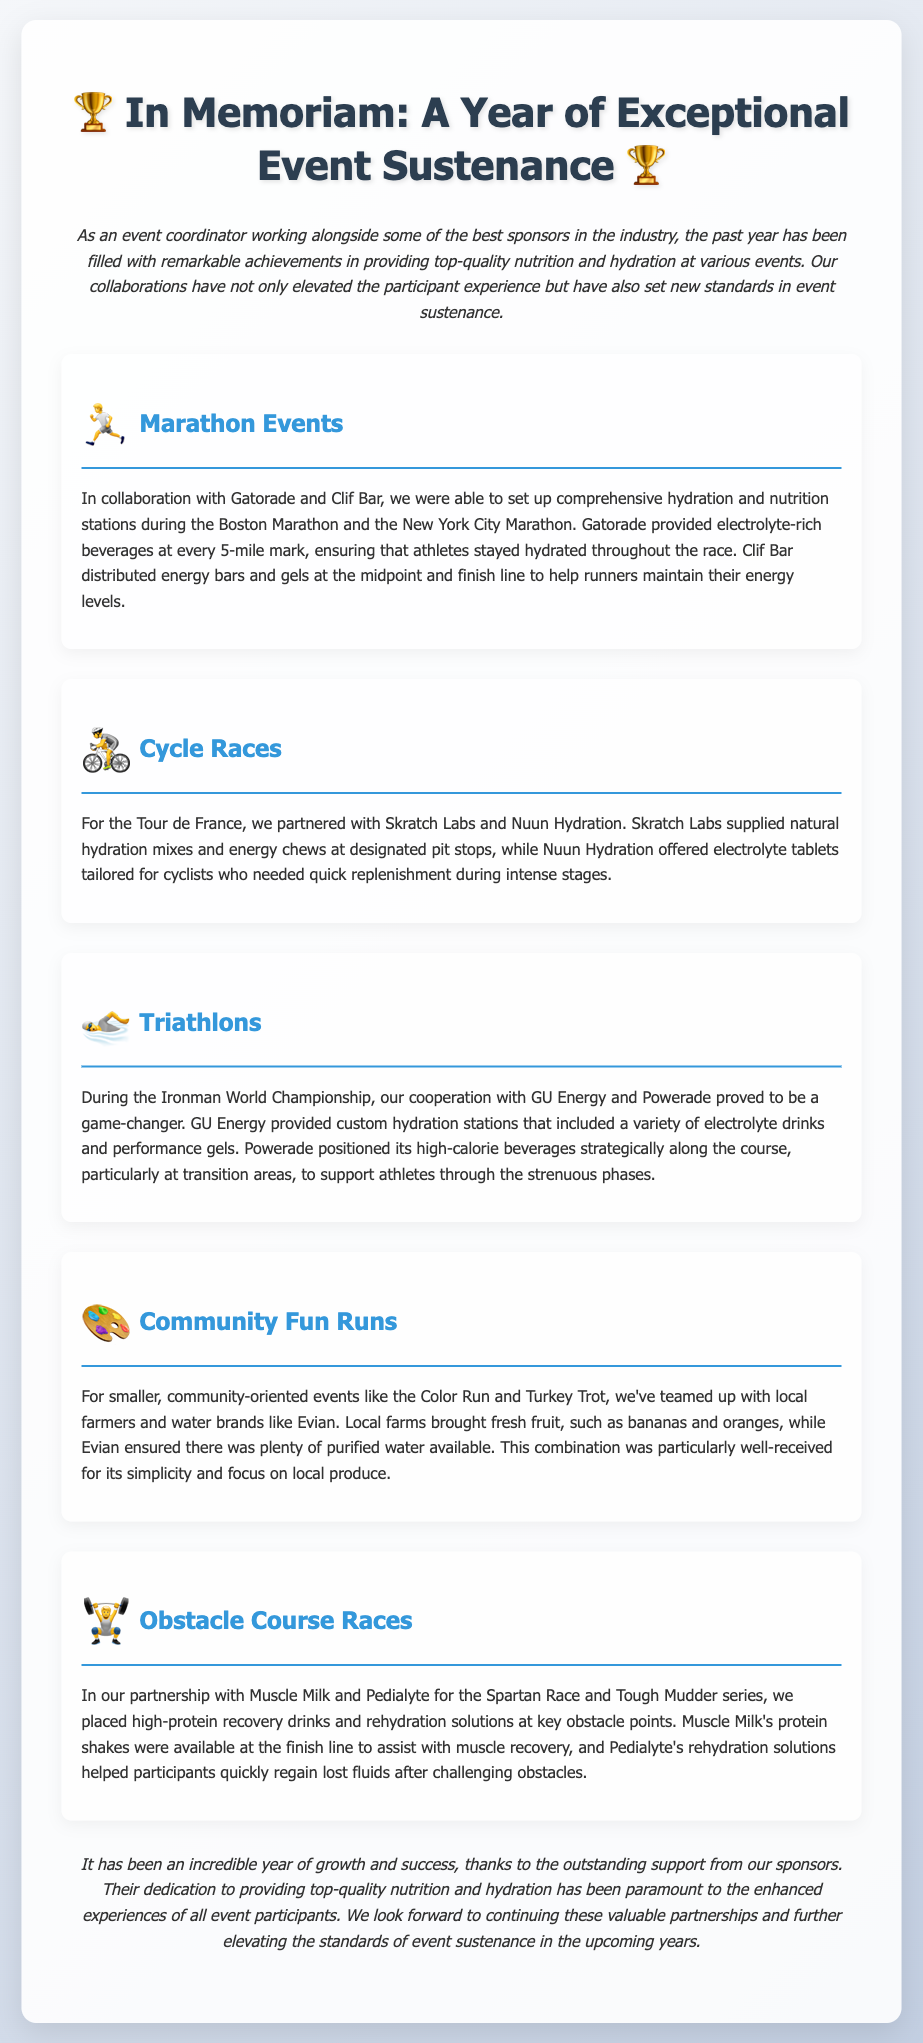What sponsors were involved in the Boston Marathon? The document states that the sponsors for the Boston Marathon were Gatorade and Clif Bar.
Answer: Gatorade and Clif Bar What hydration products did Skratch Labs provide during the Tour de France? The document mentions that Skratch Labs supplied natural hydration mixes and energy chews.
Answer: Natural hydration mixes and energy chews At which events did Powerade provide high-calorie beverages? According to the document, Powerade provided high-calorie beverages during the Ironman World Championship.
Answer: Ironman World Championship What types of fruit were provided by local farms for community events? The document lists bananas and oranges as the fruits brought by local farms.
Answer: Bananas and oranges Which brand was responsible for protein shakes at the Spartan Race? The document mentions Muscle Milk as the brand responsible for protein shakes at the Spartan Race.
Answer: Muscle Milk How many marathon events were highlighted in the document? The document specifically highlights two marathon events: the Boston Marathon and the New York City Marathon.
Answer: Two What is the general reaction to the nutrition provided at the community fun runs? The document describes the combination of local produce and purified water as particularly well-received.
Answer: Particularly well-received What type of rehydration solutions did Pedialyte provide? The document indicates that Pedialyte provided rehydration solutions for participants.
Answer: Rehydration solutions What was the focus of the collaborations with local sponsors at community events? The document states that the focus was on local produce and simplicity.
Answer: Local produce and simplicity 